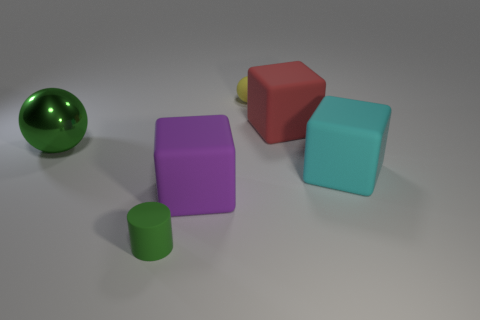What number of tiny matte objects are both behind the large cyan cube and in front of the purple matte object?
Provide a succinct answer. 0. Do the purple rubber cube and the red matte object have the same size?
Give a very brief answer. Yes. Do the green object that is in front of the shiny ball and the yellow ball have the same size?
Keep it short and to the point. Yes. What color is the matte block that is to the left of the yellow matte ball?
Offer a very short reply. Purple. What number of big purple cubes are there?
Provide a succinct answer. 1. There is a large red thing that is the same material as the big cyan thing; what is its shape?
Your response must be concise. Cube. There is a tiny thing that is in front of the big red object; is it the same color as the ball that is in front of the big red rubber thing?
Ensure brevity in your answer.  Yes. Are there an equal number of large cyan blocks behind the big shiny ball and large purple rubber blocks?
Your answer should be compact. No. What number of yellow rubber things are to the right of the shiny ball?
Make the answer very short. 1. What is the size of the green shiny thing?
Your response must be concise. Large. 